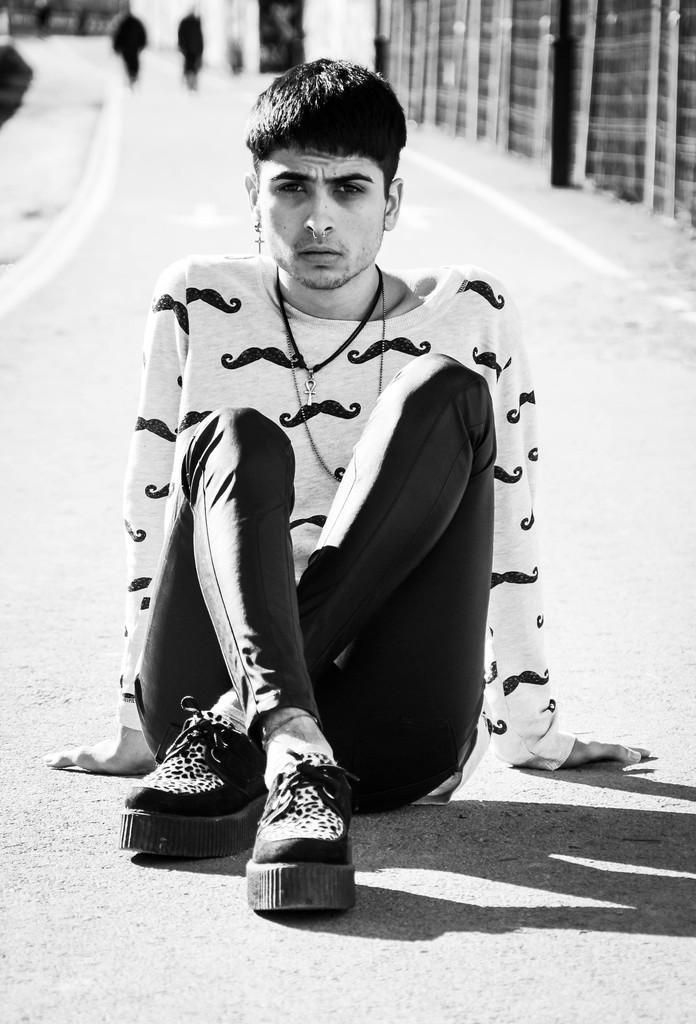Can you describe this image briefly? In this picture there is a boy who is sitting on the road in the center of the image and there are other people and buildings at the top side of the image. 